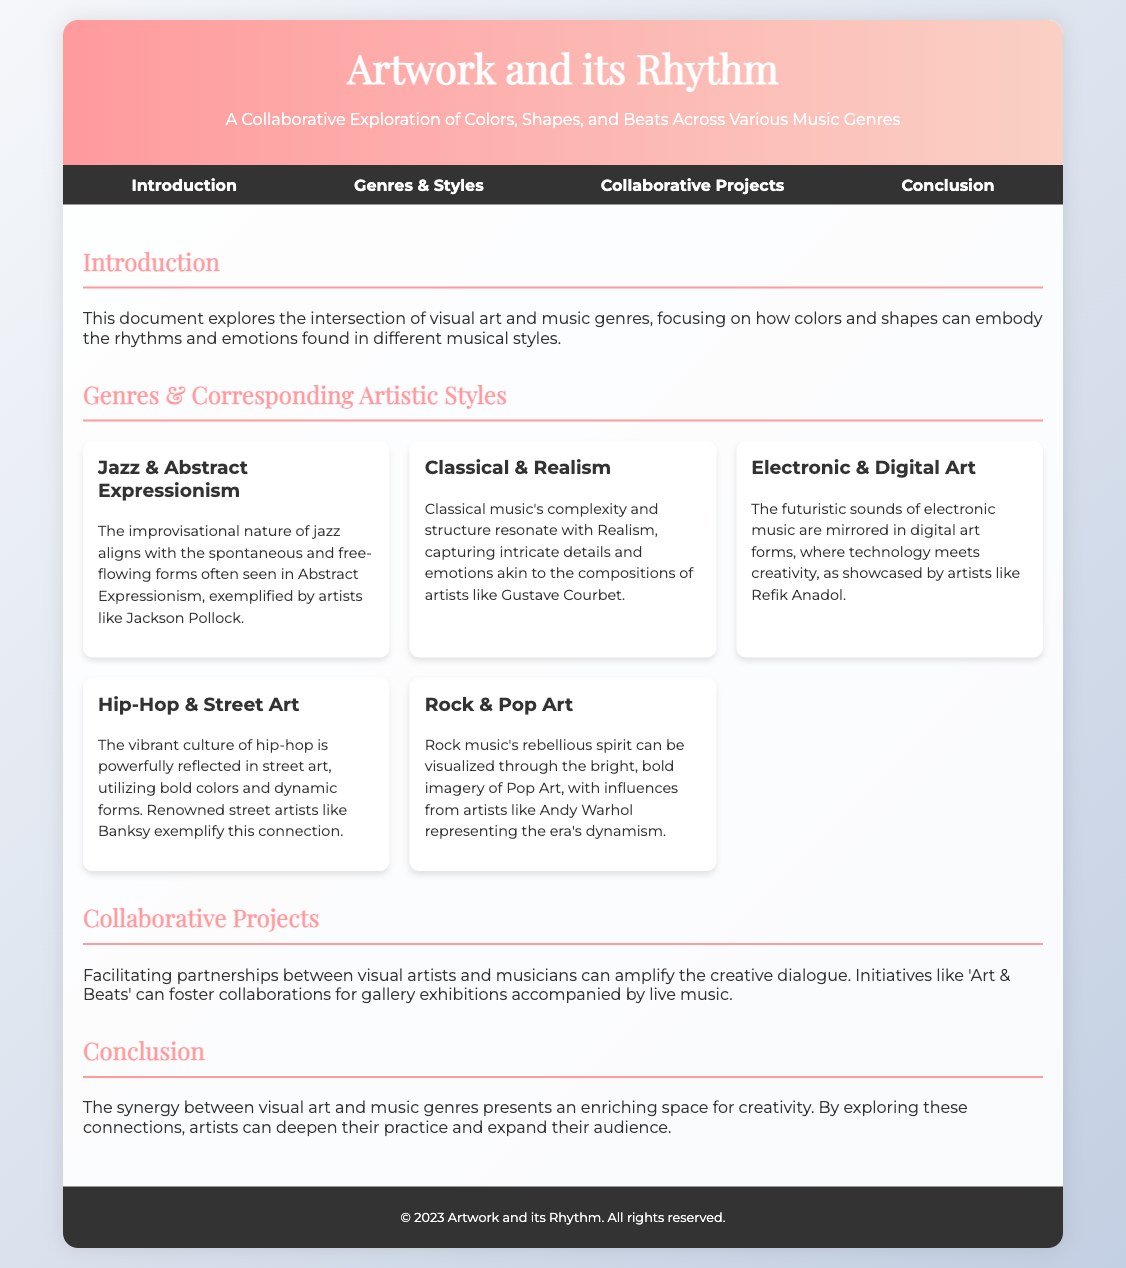What is the title of the document? The title is stated at the top of the document, reflecting the main theme of the content.
Answer: Artwork and its Rhythm What are the artistic styles associated with Jazz? The document lists corresponding artistic styles for each music genre, where Jazz is paired with Abstract Expressionism.
Answer: Abstract Expressionism Who is a renowned street artist mentioned in connection with Hip-Hop? The document provides examples of artists that exemplify the connection with their genres, specifically mentioning one for Hip-Hop.
Answer: Banksy What is the name of the section that discusses collaborative projects? The document contains a distinct section dedicated to collaborative efforts between artists and musicians, providing its heading in the navigation.
Answer: Collaborative Projects Which music genre aligns with Realism? The document explains the relationship between music genres and artistic styles, identifying Classical with Realism.
Answer: Classical What type of art is connected with Electronic music? Electronic music's artistic counterpart is discussed, indicating a specific form of visual art that fits with this genre.
Answer: Digital Art What initiative is mentioned to facilitate partnerships between visual artists and musicians? The document proposes a specific initiative aimed at fostering collaboration in its discussion of projects.
Answer: Art & Beats How many genre and artistic style pairs are presented in the document? The document includes a specific number of genre and corresponding artistic style connections outlined in the sections.
Answer: Five 